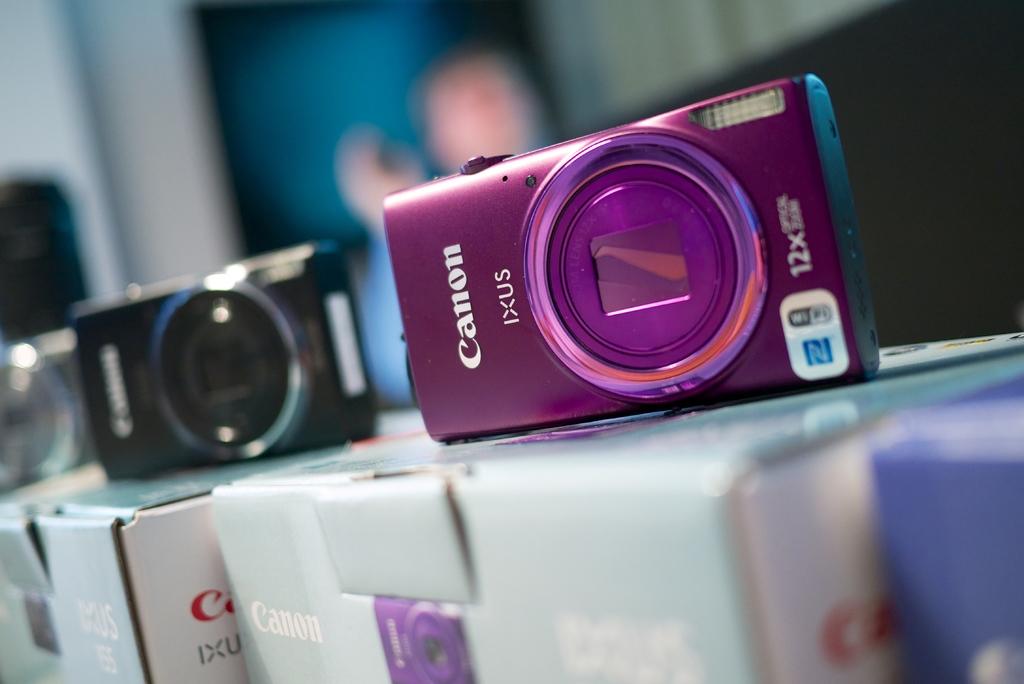What brand of camera?
Keep it short and to the point. Canon. What is the model of this camera?
Your answer should be compact. Ixus. 